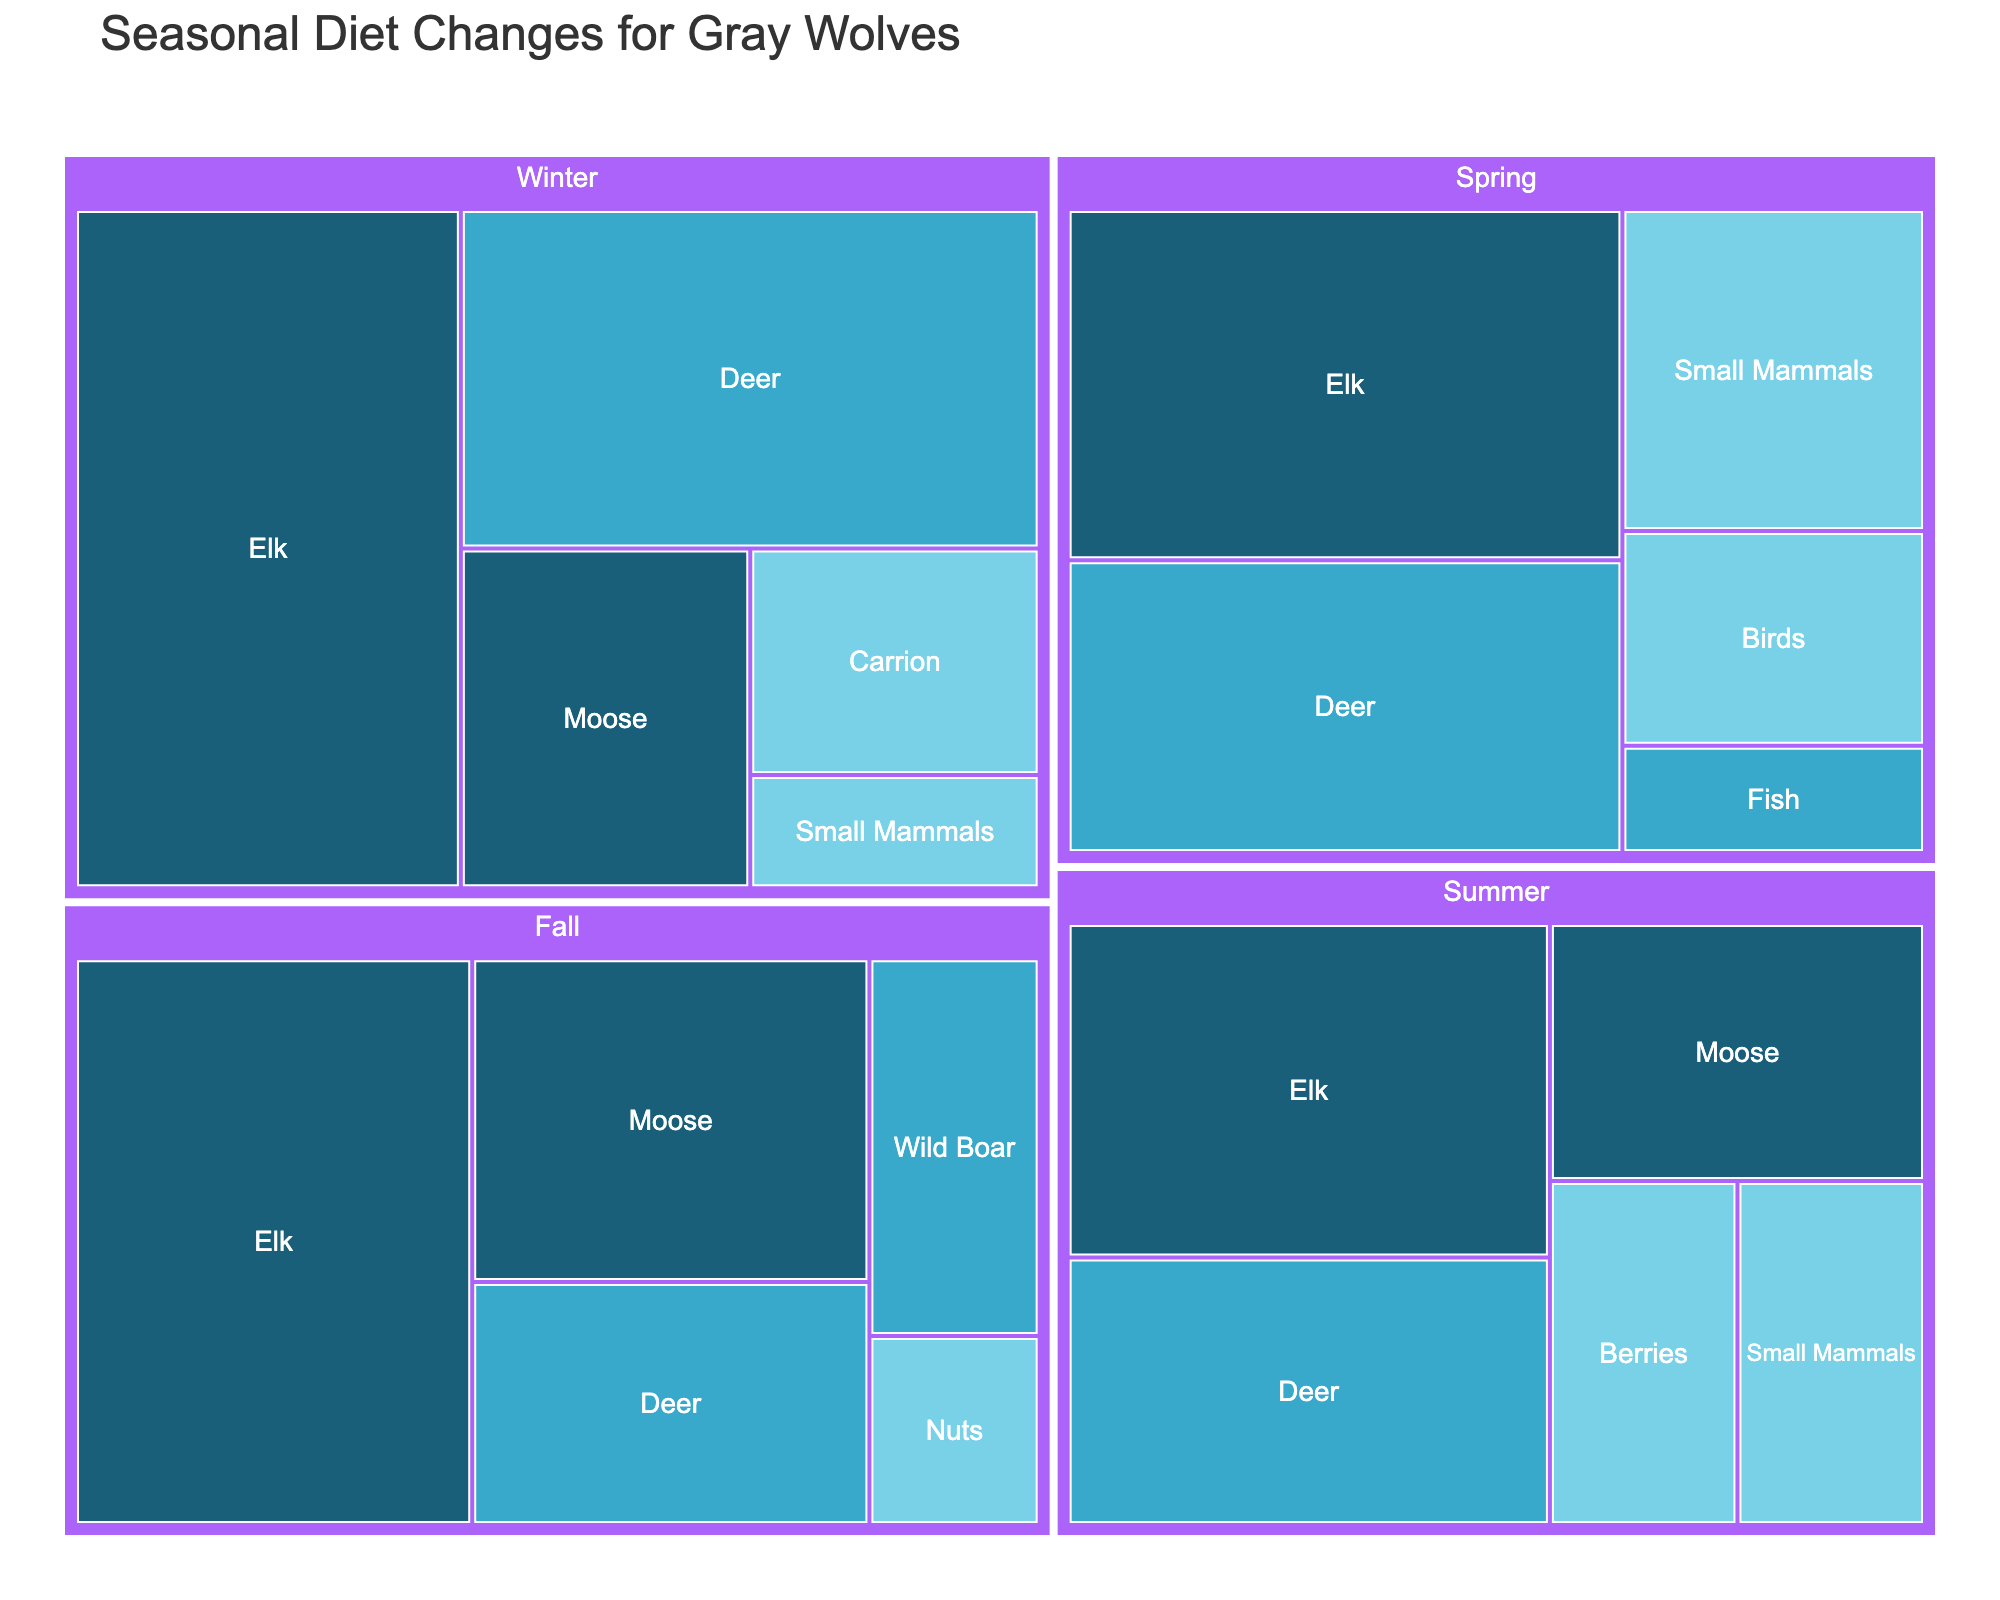What season has the highest percentage of elk in the gray wolf's diet? To determine which season has the highest percentage of elk, we look at each segment representing elk across all seasons. The percentages are: Spring (30%), Summer (25%), Fall (35%), Winter (40%). The highest percentage is in Winter.
Answer: Winter Which food source has the highest nutritional value percentage in the fall? To answer this, we look for the food sources in the fall and then identify the ones with a 'High' nutritional value: Elk (35%) and Moose (20%). Elk has the highest percentage.
Answer: Elk How does the percentage of small mammals in winter compare to that in spring? To compare the percentages, we identify the small mammals' percentages: Winter (5%) and Spring (15%). Comparing these, 5% in winter is less than 15% in spring.
Answer: Less What is the combined percentage of high nutritional value food sources in summer? First, identify high nutritional value food sources in summer: Elk (25%), Moose (15%). Sum them up: 25% + 15% = 40%.
Answer: 40% Which season shows the highest variety of food sources? To find the season with the highest variety, count the food sources for each season: Spring (5 sources), Summer (5 sources), Fall (5 sources), Winter (4 sources). The highest variety is in Spring, Summer, and Fall with 5 sources each.
Answer: Spring, Summer, Fall What is the difference in elk percentage between fall and summer? To determine the difference, identify the elk percentages in Fall (35%) and Summer (25%). Subtract: 35% - 25% = 10%.
Answer: 10% How does the percentage of low nutritional value food sources change from spring to winter? To answer this, we sum the low nutritional value percentages for Spring and Winter. Spring: Small Mammals (15%) + Birds (10%) = 25%. Winter: Carrion (10%) + Small Mammals (5%) = 15%. Then, find the change: 25% in Spring to 15% in Winter, which is a decrease of 10%.
Answer: Decreases by 10% Which two seasons have equal percentages of deer in the wolf's diet? To determine this, we look at the percentage of deer for each season: Spring (25%), Summer (20%), Fall (15%), Winter (30%). There are no two seasons with equal percentages.
Answer: None What is the percentage difference between medium nutritional value food sources in spring and fall? Sum medium nutritional value percentages in Spring and Fall. Spring: Deer (25%) + Fish (5%) = 30%. Fall: Deer (15%) + Wild Boar (10%) = 25%. Find the difference: 30% - 25% = 5%.
Answer: 5% 